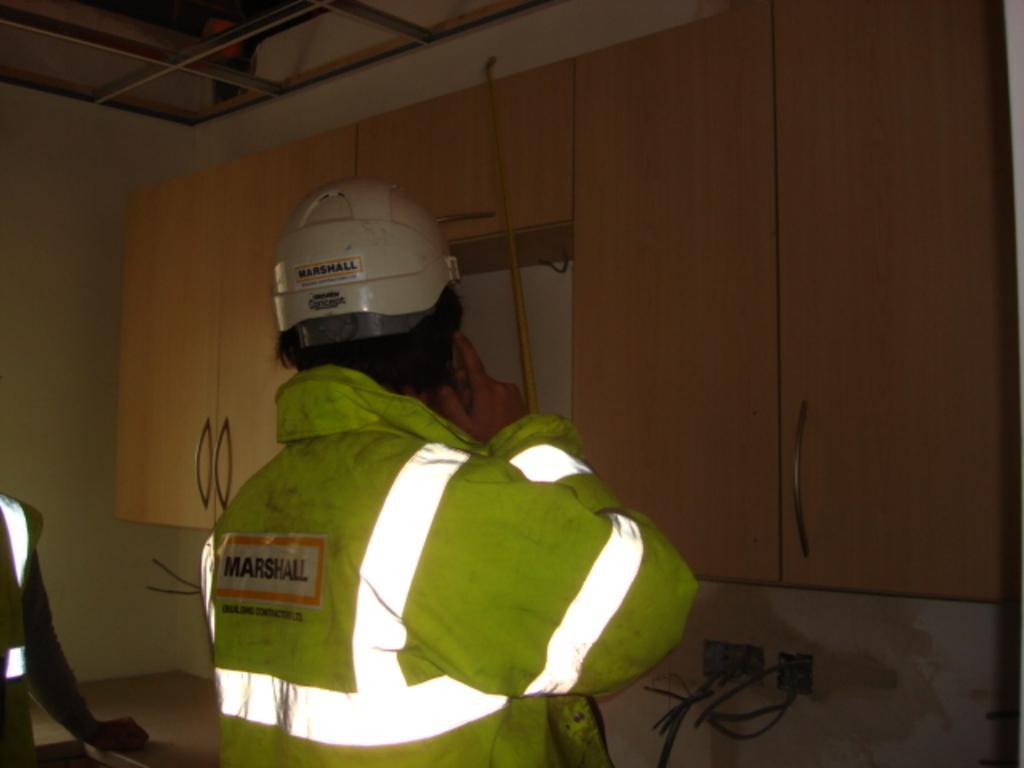In one or two sentences, can you explain what this image depicts? As we can see in the image there are two people, cupboards and the person over here is wearing a helmet. The image is little dark. 